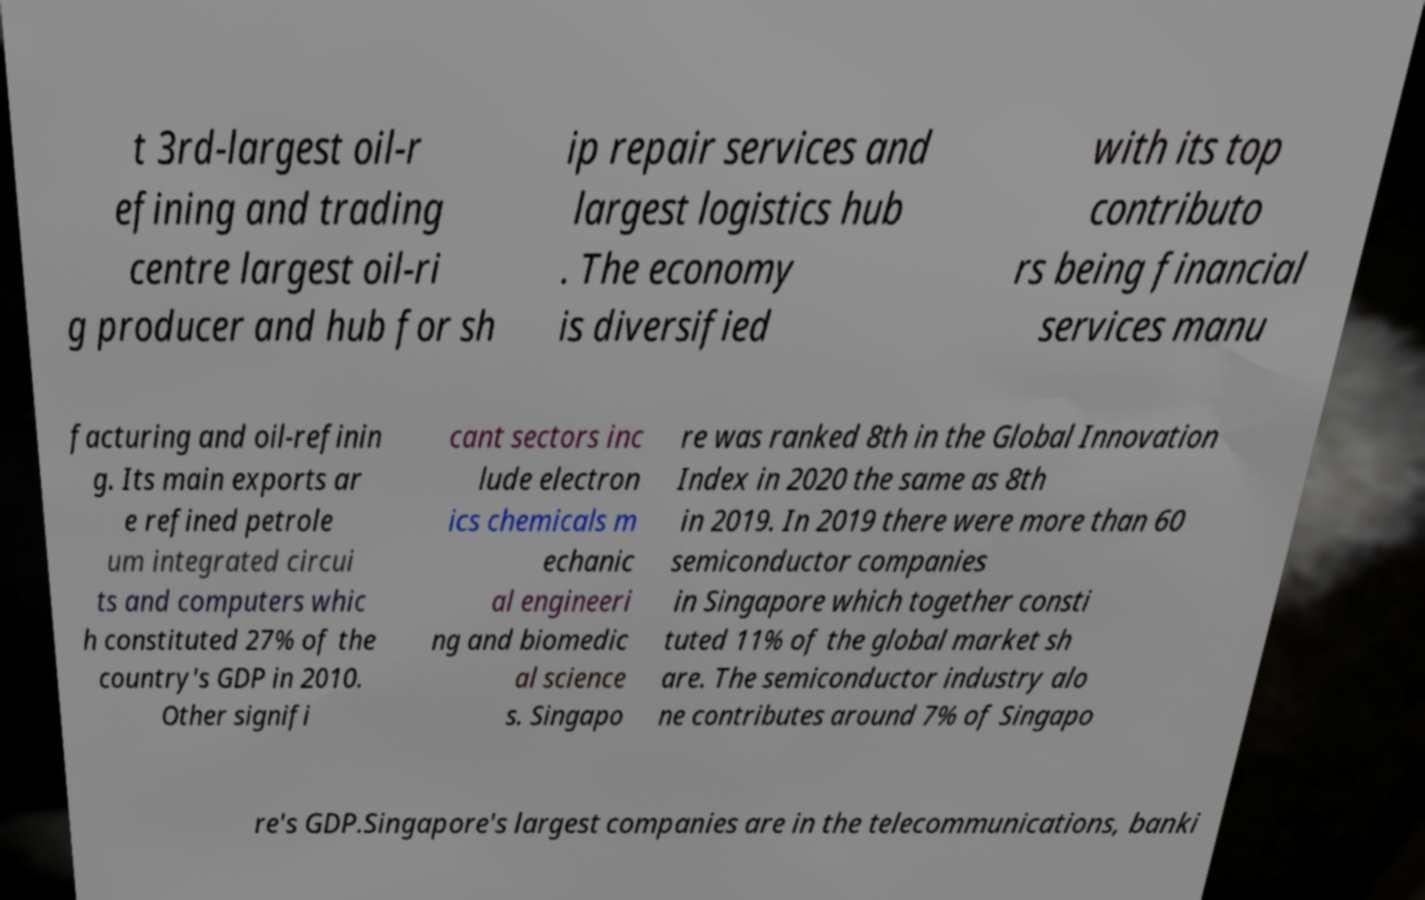What messages or text are displayed in this image? I need them in a readable, typed format. t 3rd-largest oil-r efining and trading centre largest oil-ri g producer and hub for sh ip repair services and largest logistics hub . The economy is diversified with its top contributo rs being financial services manu facturing and oil-refinin g. Its main exports ar e refined petrole um integrated circui ts and computers whic h constituted 27% of the country's GDP in 2010. Other signifi cant sectors inc lude electron ics chemicals m echanic al engineeri ng and biomedic al science s. Singapo re was ranked 8th in the Global Innovation Index in 2020 the same as 8th in 2019. In 2019 there were more than 60 semiconductor companies in Singapore which together consti tuted 11% of the global market sh are. The semiconductor industry alo ne contributes around 7% of Singapo re's GDP.Singapore's largest companies are in the telecommunications, banki 